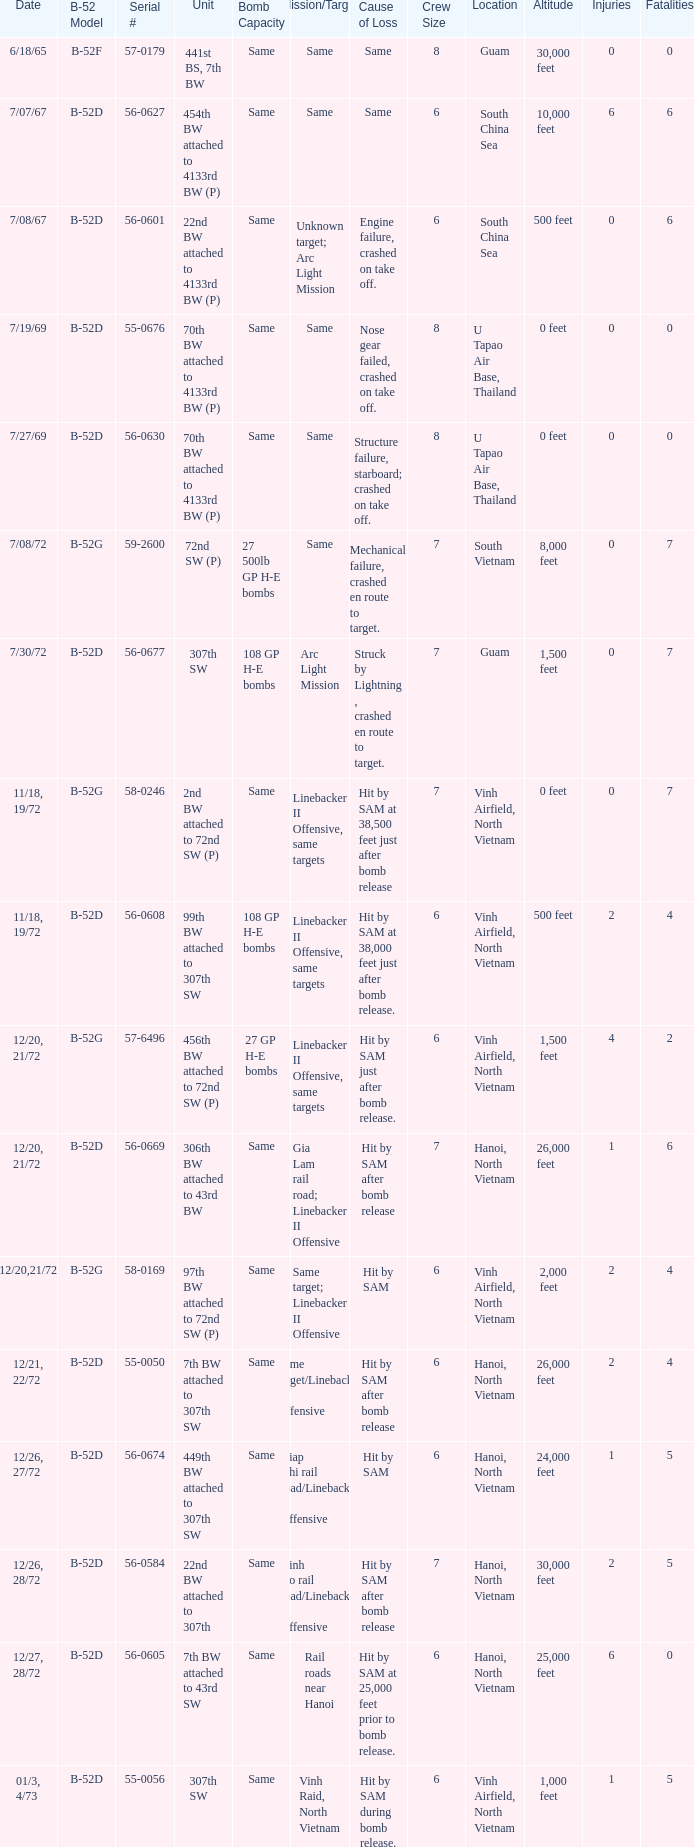Parse the full table. {'header': ['Date', 'B-52 Model', 'Serial #', 'Unit', 'Bomb Capacity', 'Mission/Target', 'Cause of Loss', 'Crew Size', 'Location', 'Altitude', 'Injuries', 'Fatalities'], 'rows': [['6/18/65', 'B-52F', '57-0179', '441st BS, 7th BW', 'Same', 'Same', 'Same', '8', 'Guam', '30,000 feet', '0', '0'], ['7/07/67', 'B-52D', '56-0627', '454th BW attached to 4133rd BW (P)', 'Same', 'Same', 'Same', '6', 'South China Sea', '10,000 feet', '6', '6'], ['7/08/67', 'B-52D', '56-0601', '22nd BW attached to 4133rd BW (P)', 'Same', 'Unknown target; Arc Light Mission', 'Engine failure, crashed on take off.', '6', 'South China Sea', '500 feet', '0', '6'], ['7/19/69', 'B-52D', '55-0676', '70th BW attached to 4133rd BW (P)', 'Same', 'Same', 'Nose gear failed, crashed on take off.', '8', 'U Tapao Air Base, Thailand', '0 feet', '0', '0'], ['7/27/69', 'B-52D', '56-0630', '70th BW attached to 4133rd BW (P)', 'Same', 'Same', 'Structure failure, starboard; crashed on take off.', '8', 'U Tapao Air Base, Thailand', '0 feet', '0', '0'], ['7/08/72', 'B-52G', '59-2600', '72nd SW (P)', '27 500lb GP H-E bombs', 'Same', 'Mechanical failure, crashed en route to target.', '7', 'South Vietnam', '8,000 feet', '0', '7'], ['7/30/72', 'B-52D', '56-0677', '307th SW', '108 GP H-E bombs', 'Arc Light Mission', 'Struck by Lightning , crashed en route to target.', '7', 'Guam', '1,500 feet', '0', '7'], ['11/18, 19/72', 'B-52G', '58-0246', '2nd BW attached to 72nd SW (P)', 'Same', 'Linebacker II Offensive, same targets', 'Hit by SAM at 38,500 feet just after bomb release', '7', 'Vinh Airfield, North Vietnam', '0 feet', '0', '7'], ['11/18, 19/72', 'B-52D', '56-0608', '99th BW attached to 307th SW', '108 GP H-E bombs', 'Linebacker II Offensive, same targets', 'Hit by SAM at 38,000 feet just after bomb release.', '6', 'Vinh Airfield, North Vietnam', '500 feet', '2', '4'], ['12/20, 21/72', 'B-52G', '57-6496', '456th BW attached to 72nd SW (P)', '27 GP H-E bombs', 'Linebacker II Offensive, same targets', 'Hit by SAM just after bomb release.', '6', 'Vinh Airfield, North Vietnam', '1,500 feet', '4', '2'], ['12/20, 21/72', 'B-52D', '56-0669', '306th BW attached to 43rd BW', 'Same', 'Gia Lam rail road; Linebacker II Offensive', 'Hit by SAM after bomb release', '7', 'Hanoi, North Vietnam', '26,000 feet', '1', '6'], ['12/20,21/72', 'B-52G', '58-0169', '97th BW attached to 72nd SW (P)', 'Same', 'Same target; Linebacker II Offensive', 'Hit by SAM', '6', 'Vinh Airfield, North Vietnam', '2,000 feet', '2', '4'], ['12/21, 22/72', 'B-52D', '55-0050', '7th BW attached to 307th SW', 'Same', 'Same target/Linebacker II Offensive', 'Hit by SAM after bomb release', '6', 'Hanoi, North Vietnam', '26,000 feet', '2', '4'], ['12/26, 27/72', 'B-52D', '56-0674', '449th BW attached to 307th SW', 'Same', 'Giap Nhi rail road/Linebacker II Offensive', 'Hit by SAM', '6', 'Hanoi, North Vietnam', '24,000 feet', '1', '5'], ['12/26, 28/72', 'B-52D', '56-0584', '22nd BW attached to 307th', 'Same', 'Kinh No rail road/Linebacker II Offensive', 'Hit by SAM after bomb release', '7', 'Hanoi, North Vietnam', '30,000 feet', '2', '5'], ['12/27, 28/72', 'B-52D', '56-0605', '7th BW attached to 43rd SW', 'Same', 'Rail roads near Hanoi', 'Hit by SAM at 25,000 feet prior to bomb release.', '6', 'Hanoi, North Vietnam', '25,000 feet', '6', '0'], ['01/3, 4/73', 'B-52D', '55-0056', '307th SW', 'Same', 'Vinh Raid, North Vietnam', 'Hit by SAM during bomb release.', '6', 'Vinh Airfield, North Vietnam', '1,000 feet', '1', '5']]} When  same target; linebacker ii offensive is the same target what is the unit? 97th BW attached to 72nd SW (P). 